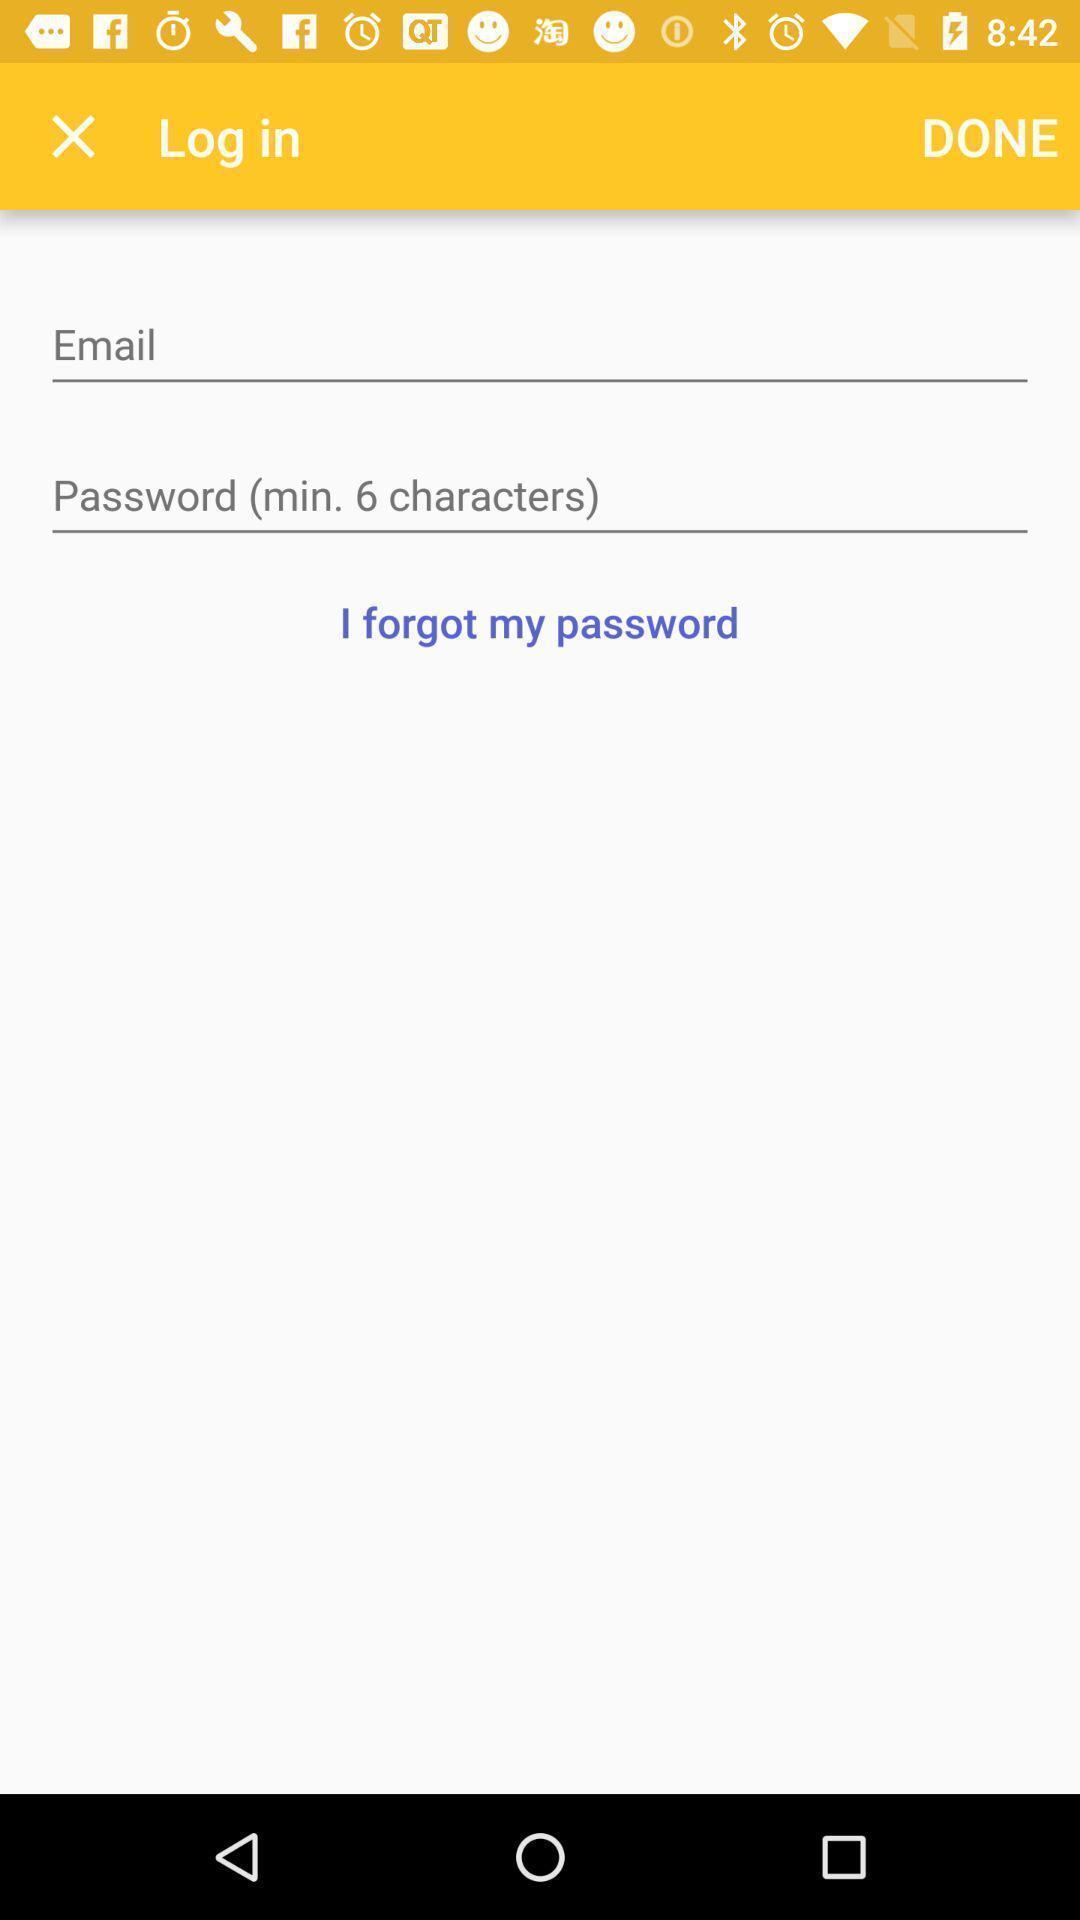Provide a detailed account of this screenshot. Login page of baby care tracking app. 